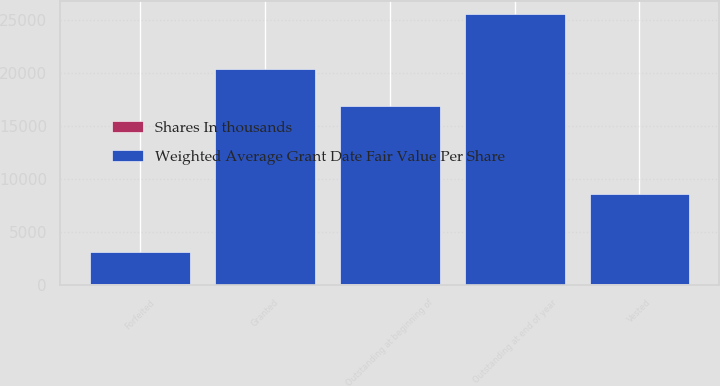Convert chart. <chart><loc_0><loc_0><loc_500><loc_500><stacked_bar_chart><ecel><fcel>Outstanding at beginning of<fcel>Granted<fcel>Vested<fcel>Forfeited<fcel>Outstanding at end of year<nl><fcel>Weighted Average Grant Date Fair Value Per Share<fcel>16813<fcel>20316<fcel>8521<fcel>3076<fcel>25532<nl><fcel>Shares In thousands<fcel>39<fcel>27<fcel>38<fcel>34<fcel>31<nl></chart> 